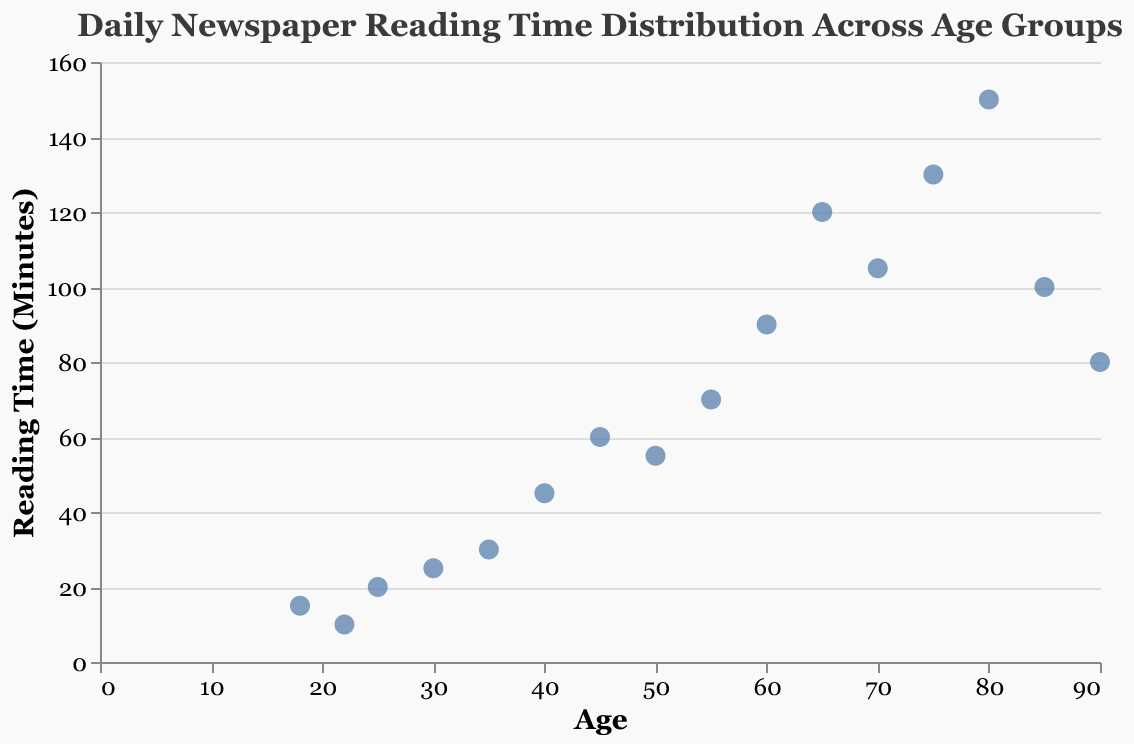How many age groups are represented in the figure? To determine the number of age groups, count the unique "Age" values in the data. The figure contains 16 different age points ranging from 18 to 90.
Answer: 16 What is the title of the figure? The title is displayed at the top of the figure. It provides context for what the figure represents. The title is "Daily Newspaper Reading Time Distribution Across Age Groups".
Answer: Daily Newspaper Reading Time Distribution Across Age Groups What is the range of the reading times in minutes? To find the range, identify the minimum and maximum values of the "Minutes" field in the data. The minimum reading time is 10 minutes and the maximum is 150 minutes, so the range is 150 - 10 = 140 minutes.
Answer: 140 Which age group has the highest reading time? Locate the highest point on the y-axis representing reading time. The highest reading time is 150 minutes, which corresponds to the age group of 80.
Answer: 80 Which age group has the lowest reading time? Locate the lowest point on the y-axis representing reading time. The lowest reading time is 10 minutes, which corresponds to the age group of 22.
Answer: 22 What is the reading time for the age group of 45? Find the data point where "Age" is 45 and look at the corresponding "Minutes" value. The reading time for the age group of 45 is 60 minutes.
Answer: 60 What is the average reading time across all age groups? To find the average, sum all "Minutes" values and divide by the number of data points. The total is 15 + 10 + 20 + 25 + 30 + 45 + 60 + 55 + 70 + 90 + 120 + 105 + 130 + 150 + 100 + 80 = 1105. There are 16 data points, so the average is 1105 / 16 = 69.06 minutes (approximately).
Answer: 69.06 Is there a visible trend in the reading times as age increases? To determine a trend, observe the pattern of data points. As age increases, reading time tends to increase as well, suggesting older age groups spend more time reading newspapers.
Answer: Yes, older age groups spend more time reading What is the difference in reading time between the age groups of 75 and 20? Identify the reading times for ages 75 and 20. Age 75 has 130 minutes, and age 20 has 10 minutes. The difference is 130 - 10 = 120 minutes.
Answer: 120 Which age groups have reading times greater than 100 minutes? Identify data points where "Minutes" is greater than 100. The age groups are 65 (120), 70 (105), 75 (130), 80 (150), and 85 (100).
Answer: 65, 70, 75, 80 